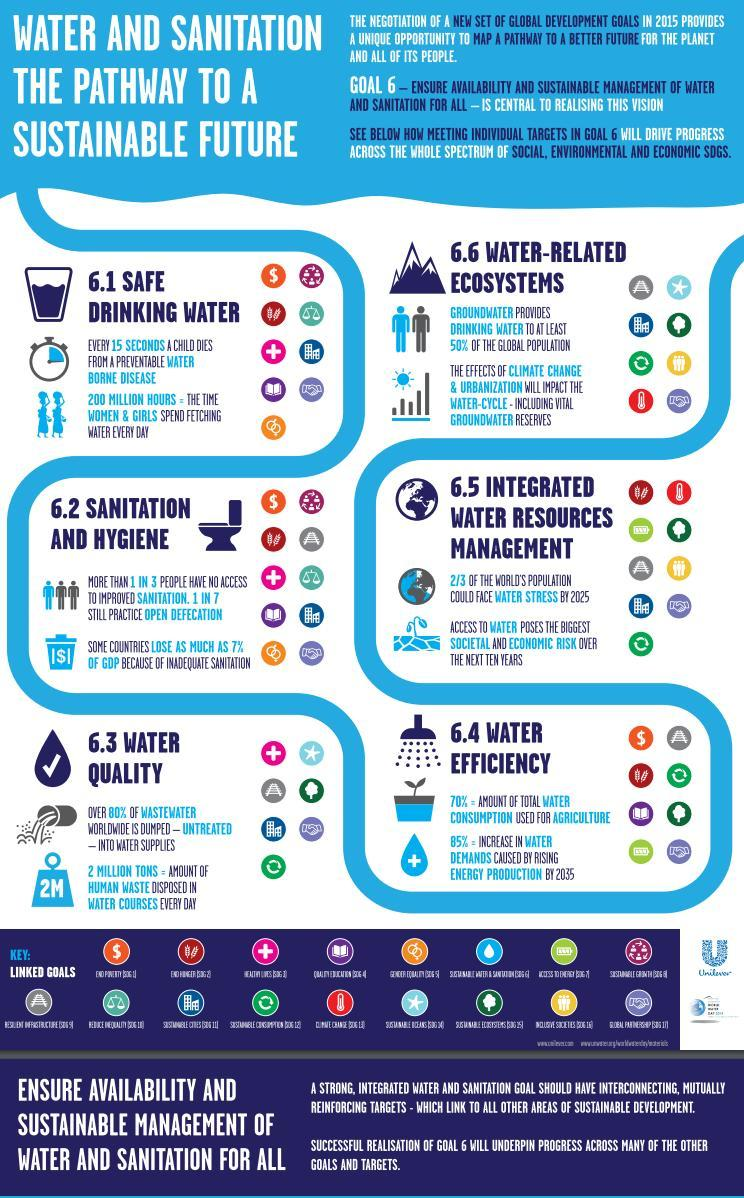What is the amount of human waste disposed in water courses everyday?
Answer the question with a short phrase. 2 MILLION TONS How much time is spend by women & girls in fetching water everyday? 200 MILLION HOURS What portion of the world's population could face water stress by 2025? 2/3 What percentage of total water consumption is used for agriculture? 70% What percentage of global population depends on ground water for drinking? 50% 